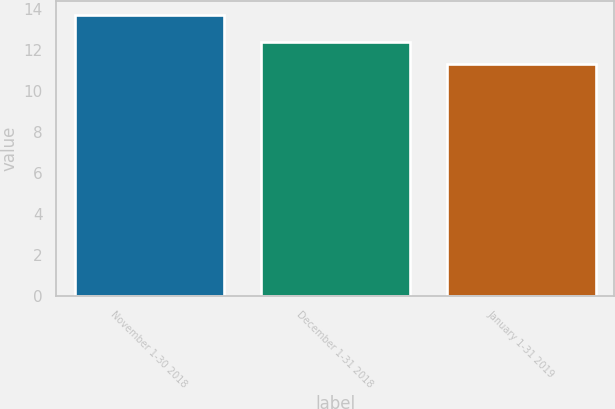<chart> <loc_0><loc_0><loc_500><loc_500><bar_chart><fcel>November 1-30 2018<fcel>December 1-31 2018<fcel>January 1-31 2019<nl><fcel>13.7<fcel>12.4<fcel>11.3<nl></chart> 